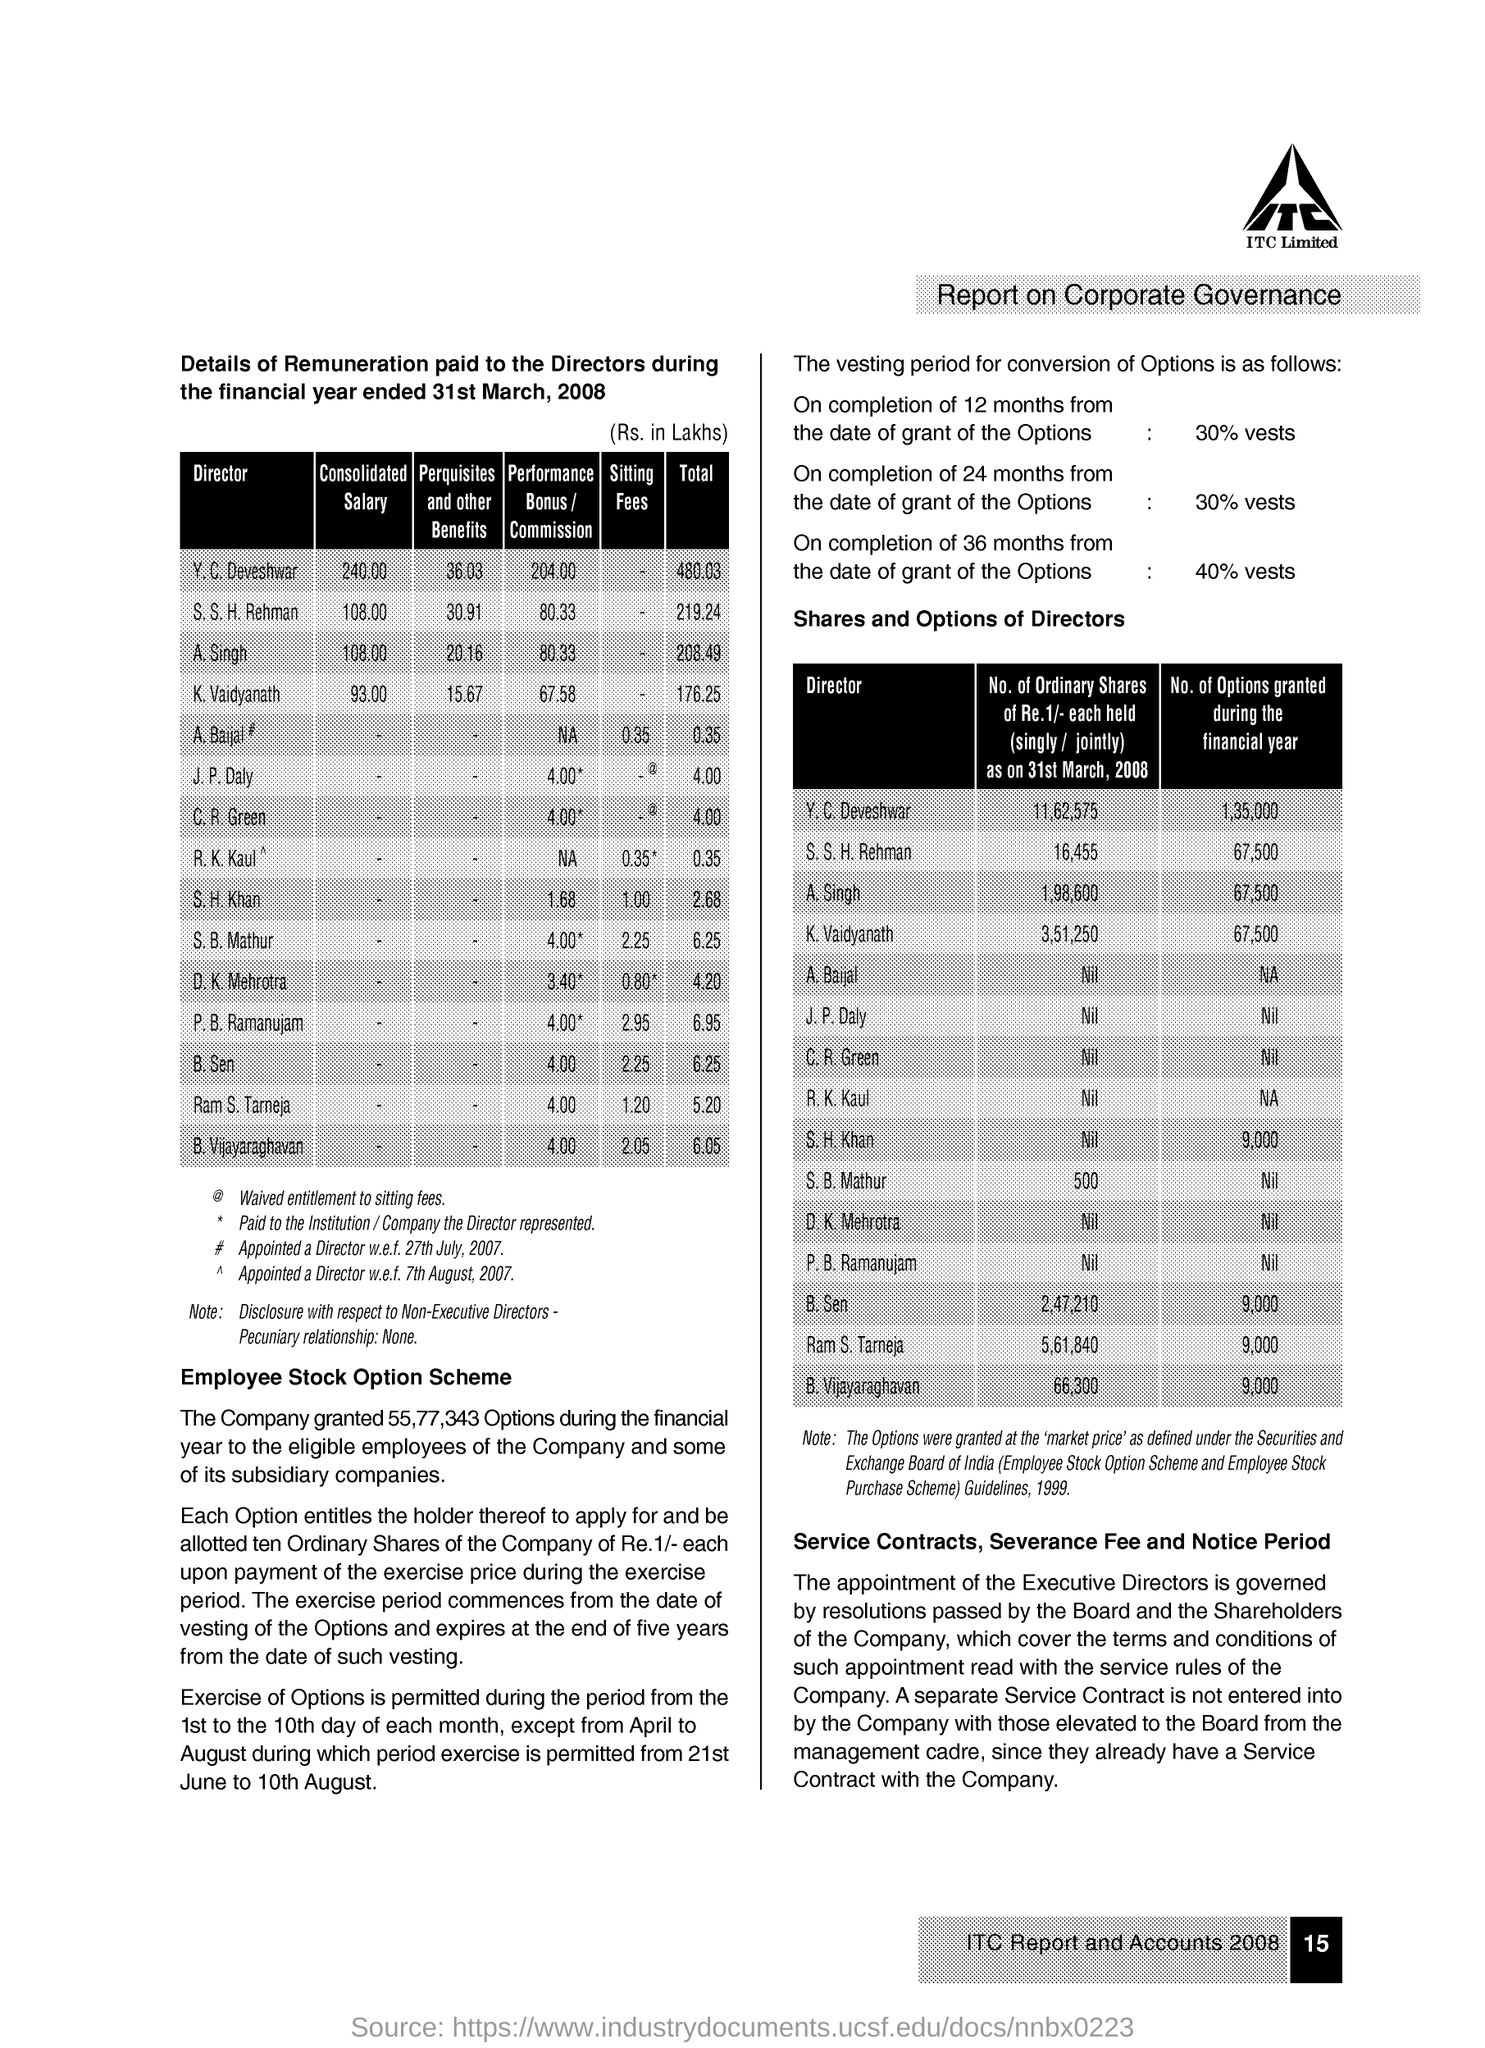What is the Consolidated Salary for Y. C. Deveshwar?
Provide a succinct answer. 240. What is the Consolidated Salary for A. Singh?
Ensure brevity in your answer.  108. What is the Consolidated Salary for K. Vaidyanath?
Your response must be concise. 93.00. What is the Consolidated Salary for S. S. H. Rehman?
Your answer should be compact. 108. What is the Total for Y. C. Deveshwar?
Your answer should be compact. 480.03. What is the Total for A. Singh?
Provide a succinct answer. 208.49. What is the Total for K. Vaidyanath?
Provide a succinct answer. 176.25. What is the Total for S. S. H. Rehman?
Ensure brevity in your answer.  219.24. What is the Sitting Fees for S. H. Khan?
Give a very brief answer. 1.00. What is the Sitting Fees for S. B. Mathur?
Provide a succinct answer. 2.25. 